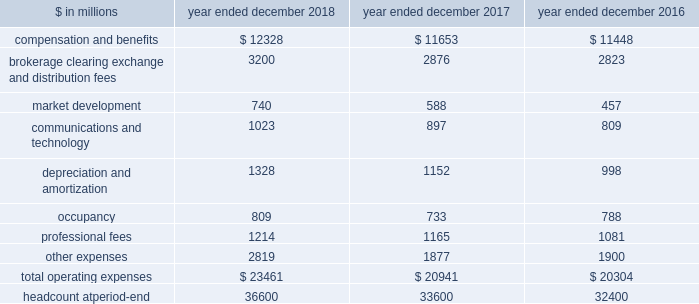The goldman sachs group , inc .
And subsidiaries management 2019s discussion and analysis 2018 versus 2017 .
Provision for credit losses in the consolidated statements of earnings was $ 674 million for 2018 , compared with $ 657 million for 2017 , as the higher provision for credit losses primarily related to consumer loan growth in 2018 was partially offset by an impairment of approximately $ 130 million on a secured loan in 2017 .
2017 versus 2016 .
Provision for credit losses in the consolidated statements of earnings was $ 657 million for 2017 , compared with $ 182 million for 2016 , reflecting an increase in impairments , which included an impairment of approximately $ 130 million on a secured loan in 2017 , and higher provision for credit losses primarily related to consumer loan growth .
Operating expenses our operating expenses are primarily influenced by compensation , headcount and levels of business activity .
Compensation and benefits includes salaries , discretionary compensation , amortization of equity awards and other items such as benefits .
Discretionary compensation is significantly impacted by , among other factors , the level of net revenues , overall financial performance , prevailing labor markets , business mix , the structure of our share-based compensation programs and the external environment .
In addition , see 201cuse of estimates 201d for further information about expenses that may arise from litigation and regulatory proceedings .
The table below presents operating expenses by line item and headcount. .
In the table above , the following reclassifications have been made to previously reported amounts to conform to the current presentation : 2030 regulatory-related fees that are paid to exchanges are now reported in brokerage , clearing , exchange and distribution fees .
Previously such amounts were reported in other expenses .
2030 headcount consists of our employees , and excludes consultants and temporary staff previously reported as part of total staff .
As a result , expenses related to these consultants and temporary staff are now reported in professional fees .
Previously such amounts were reported in compensation and benefits expenses .
2018 versus 2017 .
Operating expenses in the consolidated statements of earnings were $ 23.46 billion for 2018 , 12% ( 12 % ) higher than 2017 .
Our efficiency ratio ( total operating expenses divided by total net revenues ) for 2018 was 64.1% ( 64.1 % ) , compared with 64.0% ( 64.0 % ) for 2017 .
The increase in operating expenses compared with 2017 was primarily due to higher compensation and benefits expenses , reflecting improved operating performance , and significantly higher net provisions for litigation and regulatory proceedings .
Brokerage , clearing , exchange and distribution fees were also higher , reflecting an increase in activity levels , and technology expenses increased , reflecting higher expenses related to computing services .
In addition , expenses related to consolidated investments and our digital lending and deposit platform increased , with the increases primarily in depreciation and amortization expenses , market development expenses and other expenses .
The increase compared with 2017 also included $ 297 million related to the recently adopted revenue recognition standard .
See note 3 to the consolidated financial statements for further information about asu no .
2014-09 , 201crevenue from contracts with customers ( topic 606 ) . 201d net provisions for litigation and regulatory proceedings for 2018 were $ 844 million compared with $ 188 million for 2017 .
2018 included a $ 132 million charitable contribution to goldman sachs gives , our donor-advised fund .
Compensation was reduced to fund this charitable contribution to goldman sachs gives .
We ask our participating managing directors to make recommendations regarding potential charitable recipients for this contribution .
As of december 2018 , headcount increased 9% ( 9 % ) compared with december 2017 , reflecting an increase in technology professionals and investments in new business initiatives .
2017 versus 2016 .
Operating expenses in the consolidated statements of earnings were $ 20.94 billion for 2017 , 3% ( 3 % ) higher than 2016 .
Our efficiency ratio for 2017 was 64.0% ( 64.0 % ) compared with 65.9% ( 65.9 % ) for 2016 .
The increase in operating expenses compared with 2016 was primarily driven by slightly higher compensation and benefits expenses and our investments to fund growth .
Higher expenses related to consolidated investments and our digital lending and deposit platform were primarily included in depreciation and amortization expenses , market development expenses and other expenses .
In addition , technology expenses increased , reflecting higher expenses related to cloud-based services and software depreciation , and professional fees increased , primarily related to consulting costs .
These increases were partially offset by lower net provisions for litigation and regulatory proceedings , and lower occupancy expenses ( primarily related to exit costs in 2016 ) .
54 goldman sachs 2018 form 10-k .
What is the growth rate in operating expenses in 2018? 
Computations: ((23461 - 20941) / 20941)
Answer: 0.12034. 